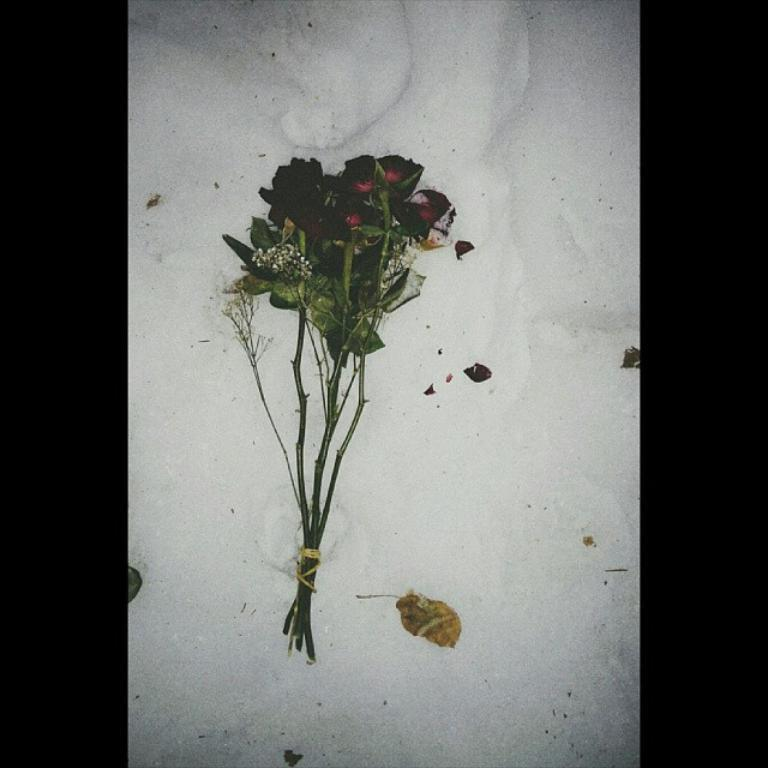What type of plants can be seen in the image? There are flowers and leaves in the image. What is the color of the surface on which the flowers and leaves are placed? The flowers and leaves are on a white surface. What can be observed about the background of the image? The background of the image is dark. What type of jeans are being worn by the trees in the image? There are no trees or jeans present in the image. What is the quiver used for in the image? There is no quiver present in the image. 